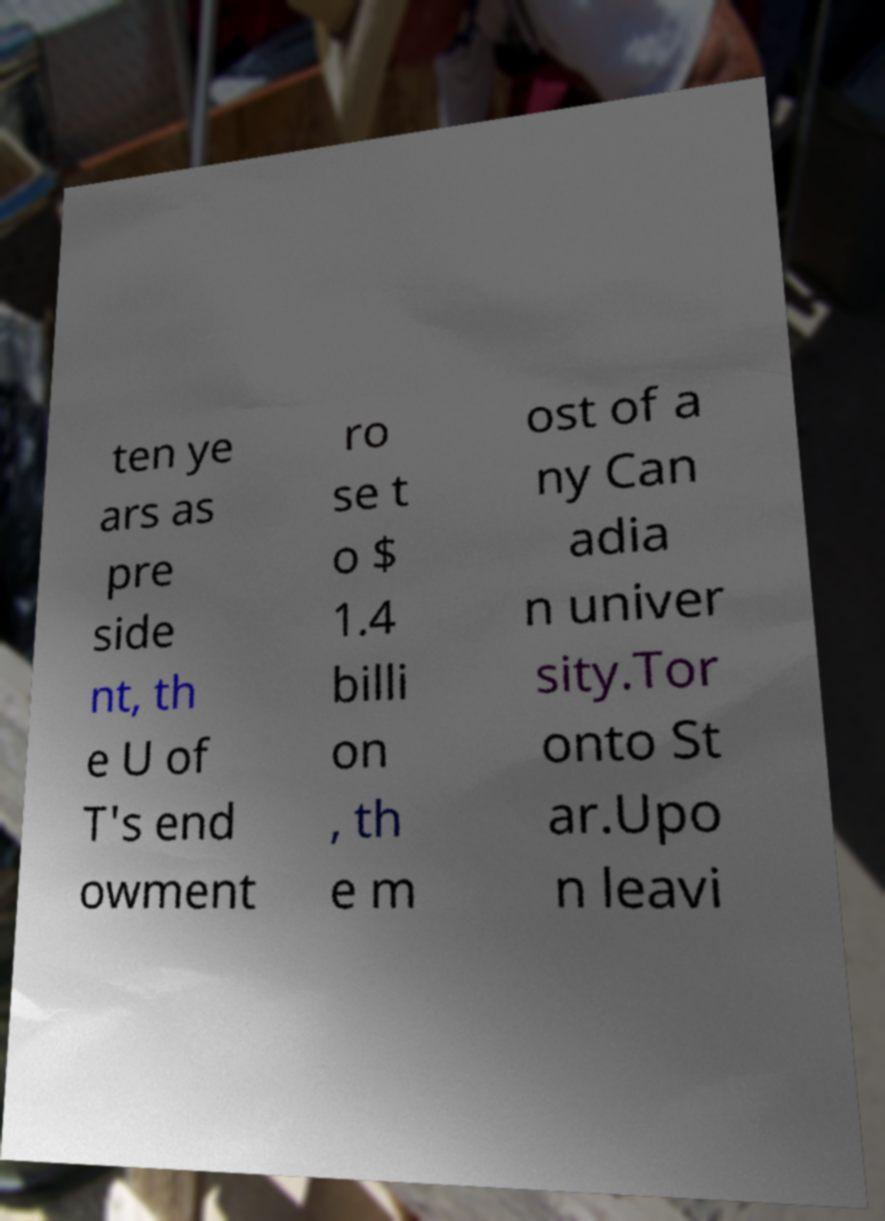Can you read and provide the text displayed in the image?This photo seems to have some interesting text. Can you extract and type it out for me? ten ye ars as pre side nt, th e U of T's end owment ro se t o $ 1.4 billi on , th e m ost of a ny Can adia n univer sity.Tor onto St ar.Upo n leavi 